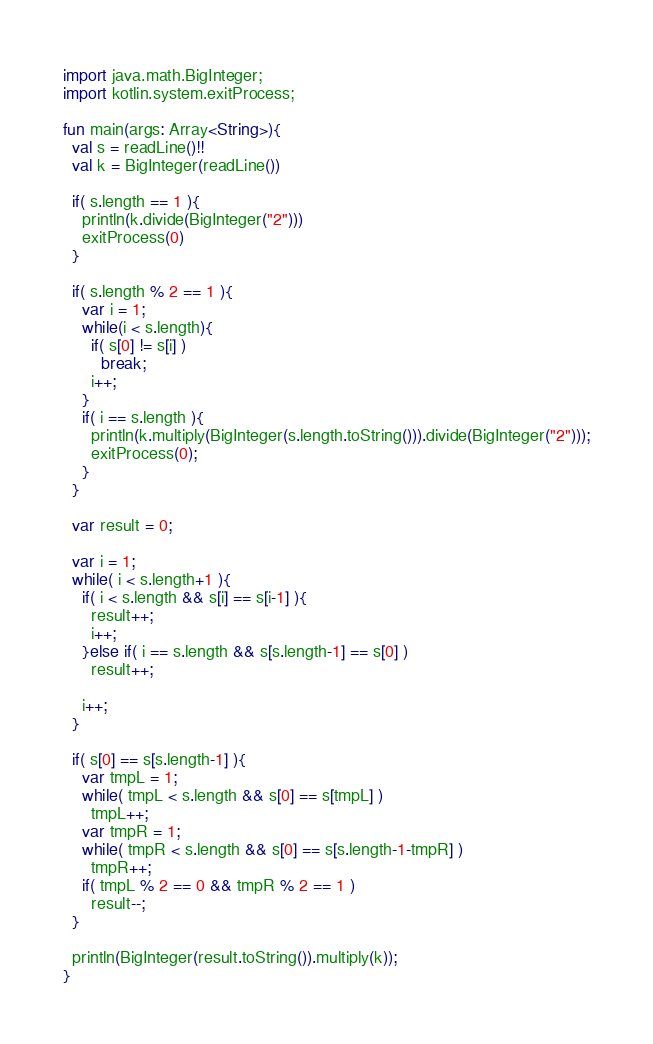<code> <loc_0><loc_0><loc_500><loc_500><_Kotlin_>import java.math.BigInteger;
import kotlin.system.exitProcess;

fun main(args: Array<String>){
  val s = readLine()!!
  val k = BigInteger(readLine())

  if( s.length == 1 ){
    println(k.divide(BigInteger("2")))
    exitProcess(0)
  }

  if( s.length % 2 == 1 ){
    var i = 1;
    while(i < s.length){
      if( s[0] != s[i] )
        break;
      i++;
    }
    if( i == s.length ){
      println(k.multiply(BigInteger(s.length.toString())).divide(BigInteger("2")));
      exitProcess(0);
    }
  }

  var result = 0;

  var i = 1;
  while( i < s.length+1 ){
    if( i < s.length && s[i] == s[i-1] ){
      result++;
      i++;
    }else if( i == s.length && s[s.length-1] == s[0] )
      result++;

    i++;
  }

  if( s[0] == s[s.length-1] ){
    var tmpL = 1;
    while( tmpL < s.length && s[0] == s[tmpL] )
      tmpL++;
    var tmpR = 1;
    while( tmpR < s.length && s[0] == s[s.length-1-tmpR] )
      tmpR++;
    if( tmpL % 2 == 0 && tmpR % 2 == 1 )
      result--;
  }

  println(BigInteger(result.toString()).multiply(k));
}
</code> 